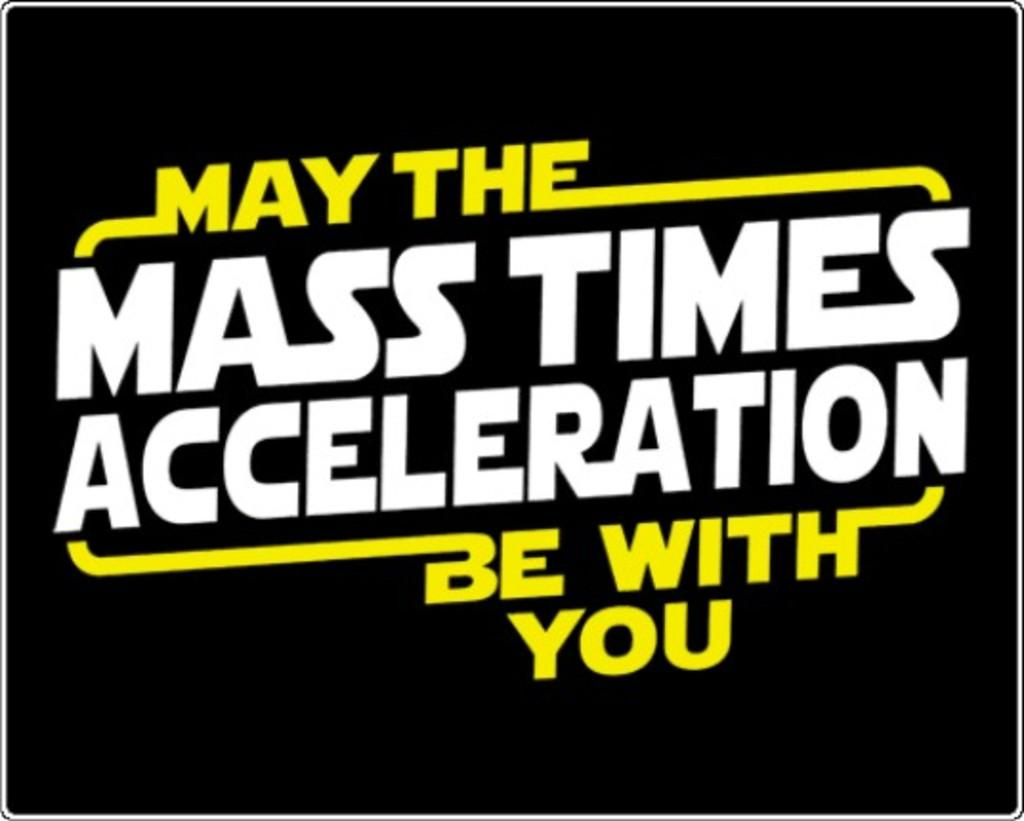<image>
Provide a brief description of the given image. A logo that says May the Mass Times Acceleration Be with you is displayed in yellow and white text. 